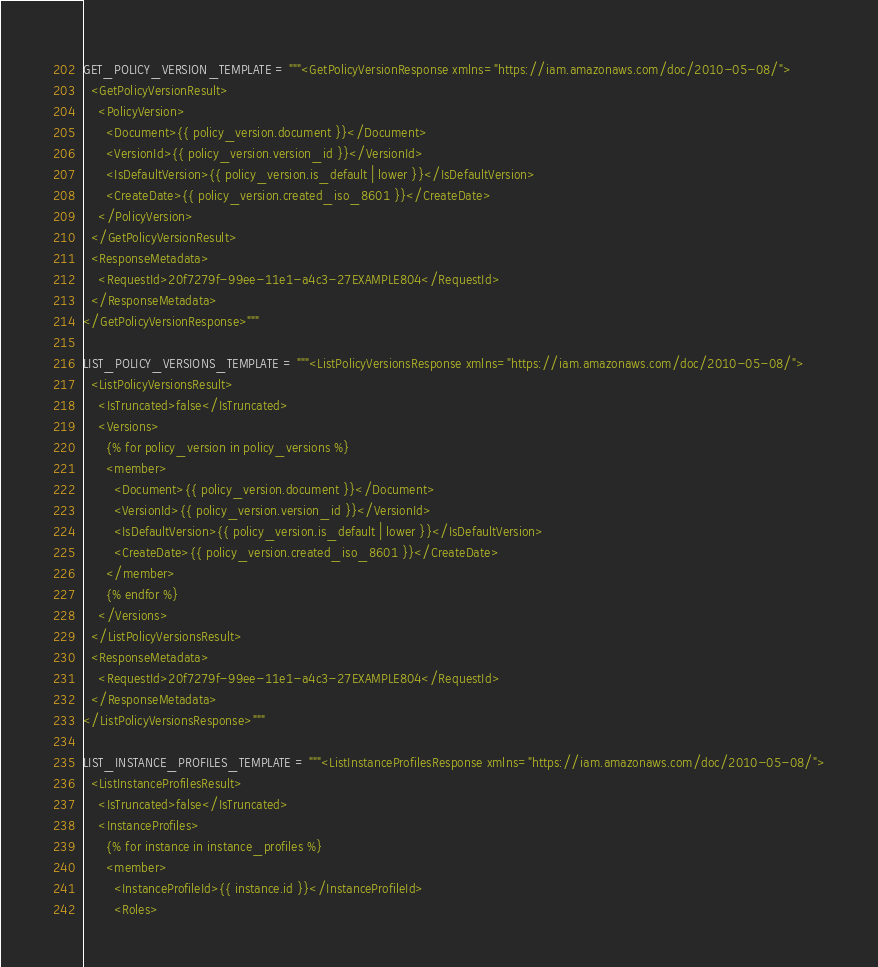Convert code to text. <code><loc_0><loc_0><loc_500><loc_500><_Python_>GET_POLICY_VERSION_TEMPLATE = """<GetPolicyVersionResponse xmlns="https://iam.amazonaws.com/doc/2010-05-08/">
  <GetPolicyVersionResult>
    <PolicyVersion>
      <Document>{{ policy_version.document }}</Document>
      <VersionId>{{ policy_version.version_id }}</VersionId>
      <IsDefaultVersion>{{ policy_version.is_default | lower }}</IsDefaultVersion>
      <CreateDate>{{ policy_version.created_iso_8601 }}</CreateDate>
    </PolicyVersion>
  </GetPolicyVersionResult>
  <ResponseMetadata>
    <RequestId>20f7279f-99ee-11e1-a4c3-27EXAMPLE804</RequestId>
  </ResponseMetadata>
</GetPolicyVersionResponse>"""

LIST_POLICY_VERSIONS_TEMPLATE = """<ListPolicyVersionsResponse xmlns="https://iam.amazonaws.com/doc/2010-05-08/">
  <ListPolicyVersionsResult>
    <IsTruncated>false</IsTruncated>
    <Versions>
      {% for policy_version in policy_versions %}
      <member>
        <Document>{{ policy_version.document }}</Document>
        <VersionId>{{ policy_version.version_id }}</VersionId>
        <IsDefaultVersion>{{ policy_version.is_default | lower }}</IsDefaultVersion>
        <CreateDate>{{ policy_version.created_iso_8601 }}</CreateDate>
      </member>
      {% endfor %}
    </Versions>
  </ListPolicyVersionsResult>
  <ResponseMetadata>
    <RequestId>20f7279f-99ee-11e1-a4c3-27EXAMPLE804</RequestId>
  </ResponseMetadata>
</ListPolicyVersionsResponse>"""

LIST_INSTANCE_PROFILES_TEMPLATE = """<ListInstanceProfilesResponse xmlns="https://iam.amazonaws.com/doc/2010-05-08/">
  <ListInstanceProfilesResult>
    <IsTruncated>false</IsTruncated>
    <InstanceProfiles>
      {% for instance in instance_profiles %}
      <member>
        <InstanceProfileId>{{ instance.id }}</InstanceProfileId>
        <Roles></code> 